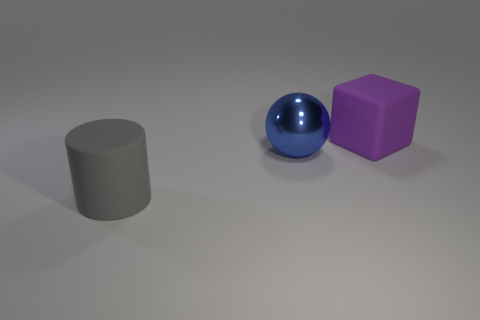Do the matte object behind the matte cylinder and the gray thing have the same size?
Ensure brevity in your answer.  Yes. What color is the big object that is both in front of the purple thing and to the right of the gray rubber cylinder?
Provide a succinct answer. Blue. What number of objects are purple metal blocks or gray matte cylinders that are to the left of the big purple rubber block?
Your answer should be compact. 1. Is there any other thing that has the same material as the big cylinder?
Your response must be concise. Yes. There is a matte thing behind the big metallic sphere; is its color the same as the cylinder?
Give a very brief answer. No. How many brown things are either matte blocks or matte things?
Provide a succinct answer. 0. Is the number of green metal cubes the same as the number of large purple objects?
Your answer should be compact. No. What number of other things are there of the same shape as the big purple thing?
Provide a succinct answer. 0. Do the blue object and the big gray thing have the same material?
Give a very brief answer. No. What is the material of the big thing that is both behind the large gray cylinder and on the left side of the purple matte object?
Give a very brief answer. Metal. 